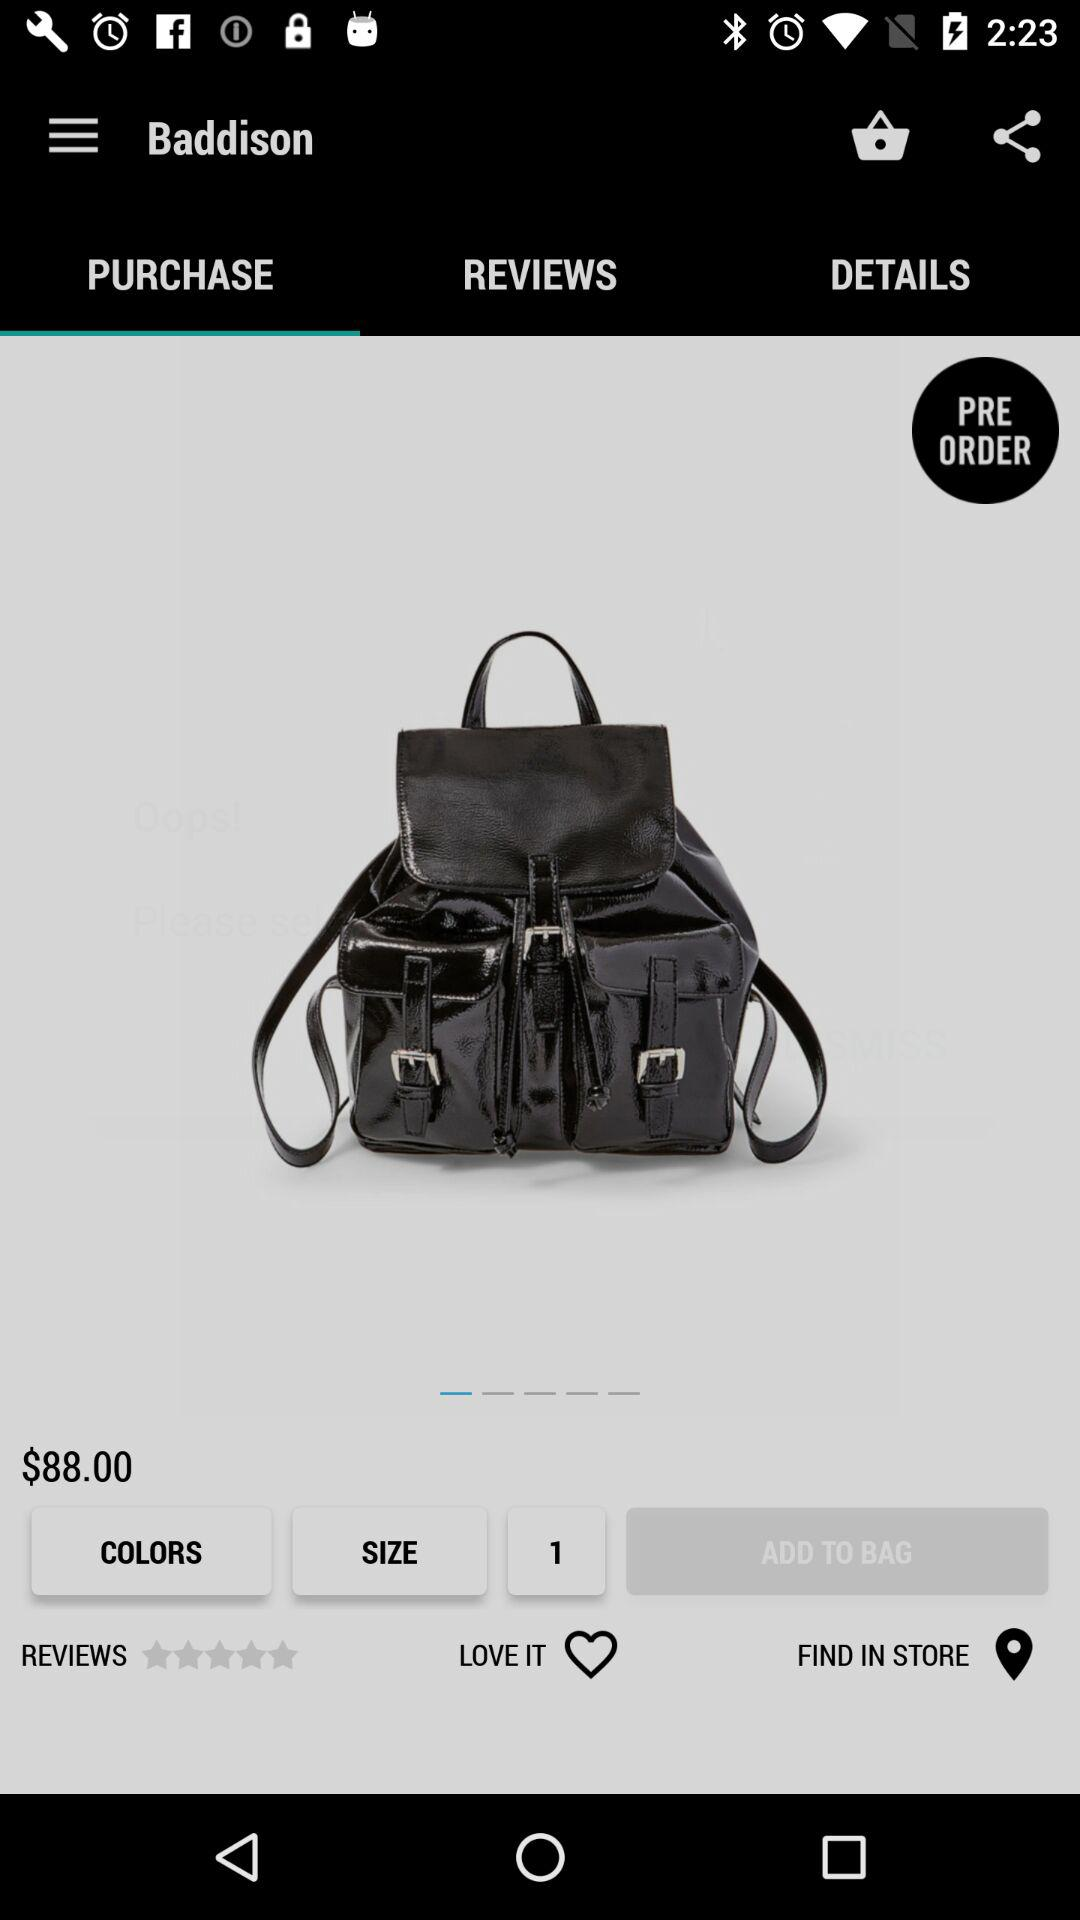How much is the backpack?
Answer the question using a single word or phrase. $88.00 